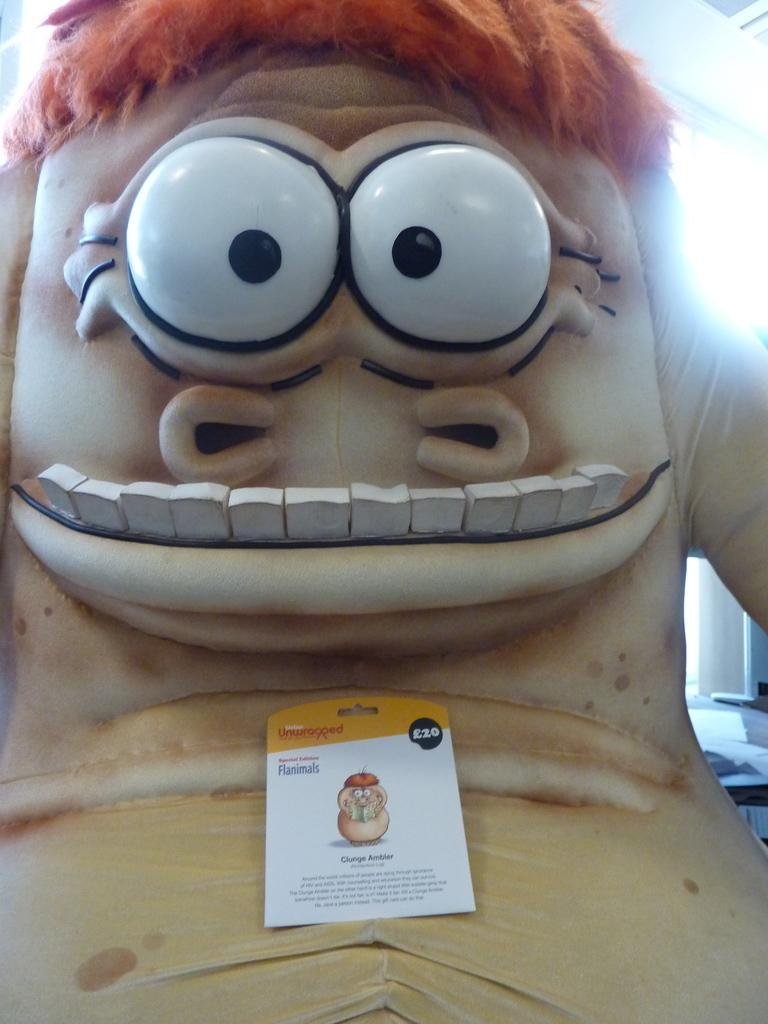What is located in the front of the image? There is a toy and a poster in the front of the image. What type of object is the toy? The provided facts do not specify the type of toy. What is depicted on the poster? There is a poster in the front of the image, but the provided facts do not specify what is depicted on it. What can be found on the poster besides the image? There is writing on the poster. Can you see any sand on the poster in the image? There is no sand present on the poster in the image. What type of animal is depicted on the poster in the image? The provided facts do not specify any animal on the poster. 